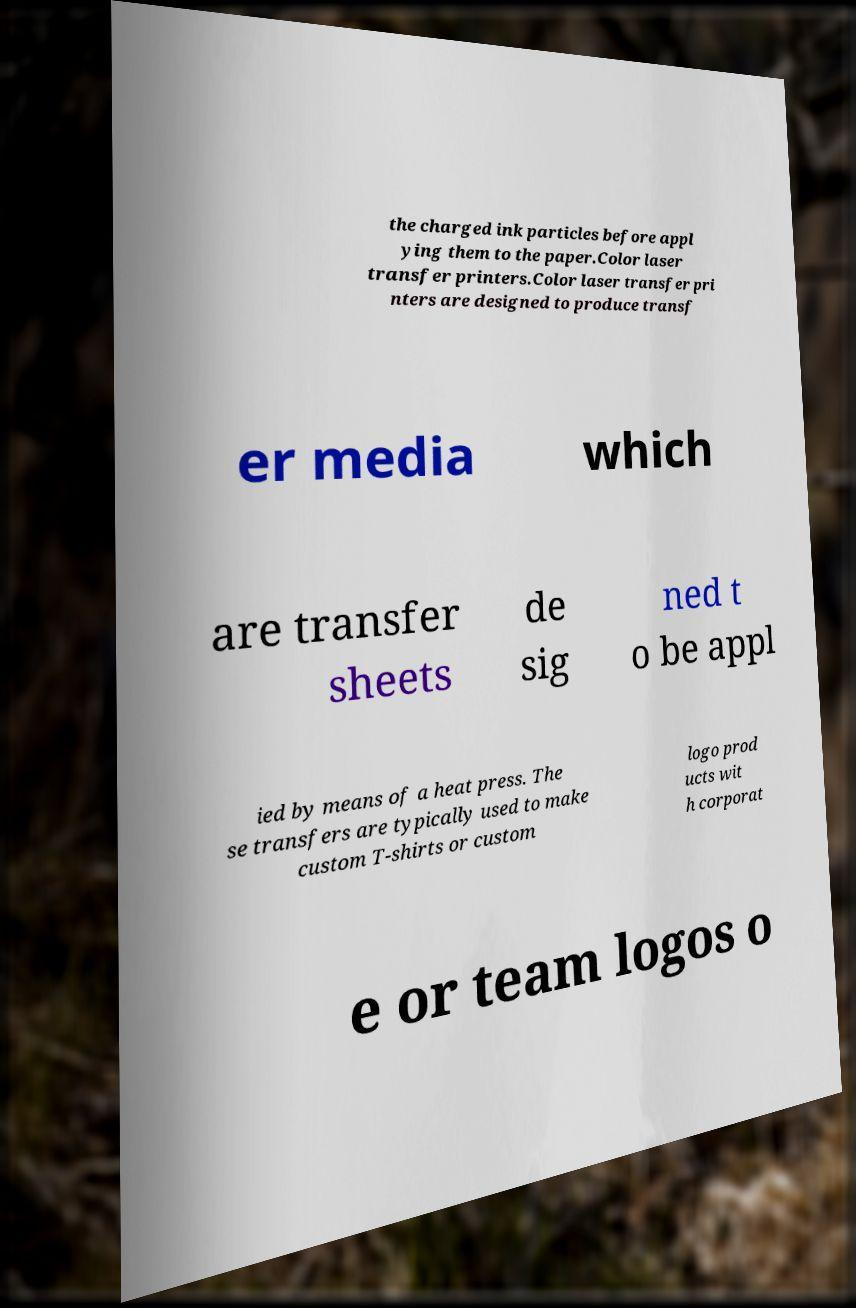Could you extract and type out the text from this image? the charged ink particles before appl ying them to the paper.Color laser transfer printers.Color laser transfer pri nters are designed to produce transf er media which are transfer sheets de sig ned t o be appl ied by means of a heat press. The se transfers are typically used to make custom T-shirts or custom logo prod ucts wit h corporat e or team logos o 